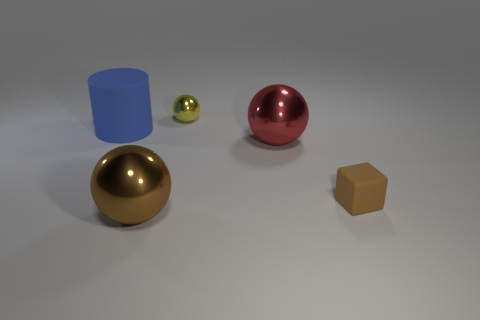Is there a large gray ball that has the same material as the tiny brown block? No, the image doesn't feature a large gray ball with the same material as the tiny brown block. Instead, it shows a large, shiny bronze sphere, a smaller matte brown cube, a medium-size shiny red sphere, a small shiny green sphere, and a matte blue cylinder. 